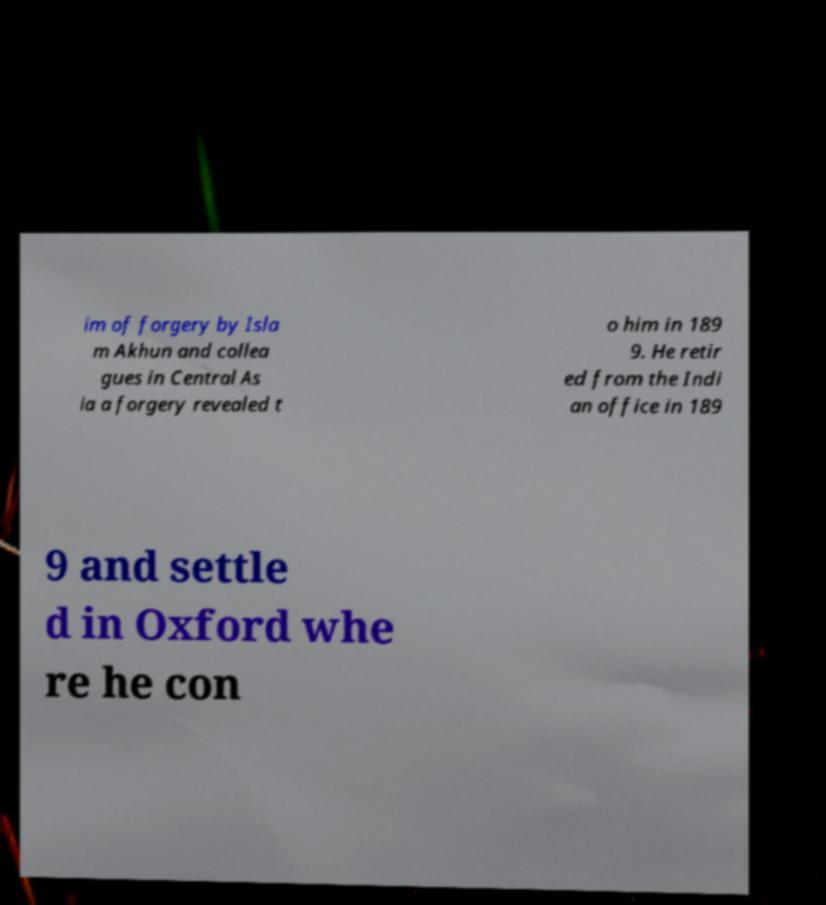Please read and relay the text visible in this image. What does it say? im of forgery by Isla m Akhun and collea gues in Central As ia a forgery revealed t o him in 189 9. He retir ed from the Indi an office in 189 9 and settle d in Oxford whe re he con 